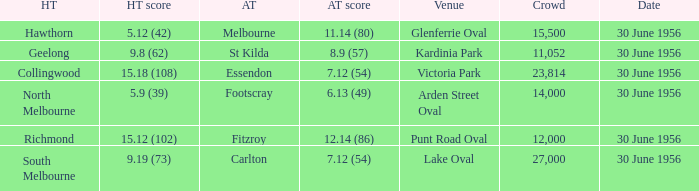What is the home team score when the away team is Melbourne? 5.12 (42). 